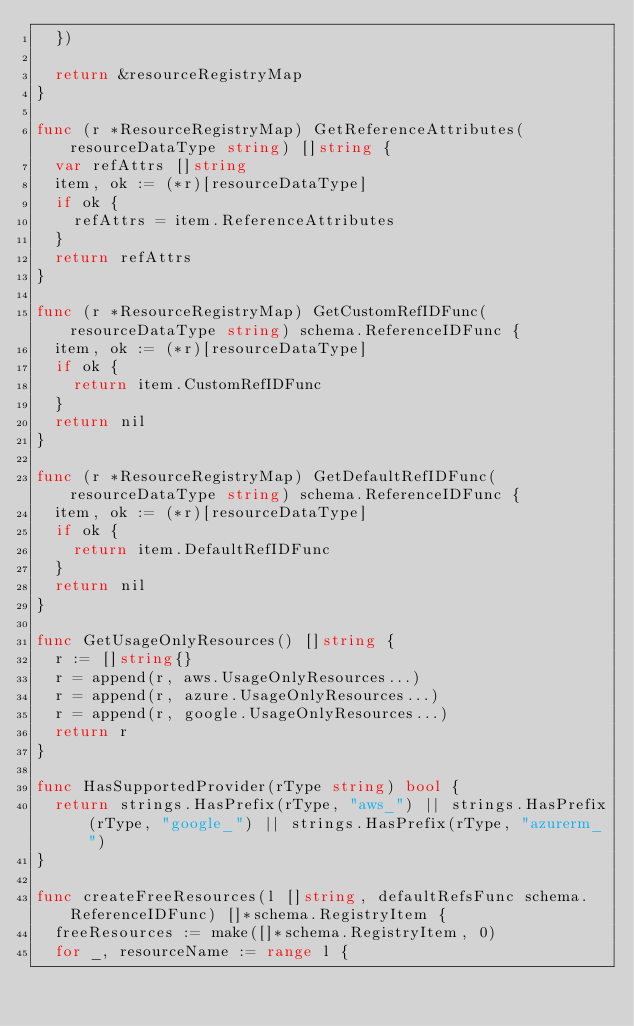Convert code to text. <code><loc_0><loc_0><loc_500><loc_500><_Go_>	})

	return &resourceRegistryMap
}

func (r *ResourceRegistryMap) GetReferenceAttributes(resourceDataType string) []string {
	var refAttrs []string
	item, ok := (*r)[resourceDataType]
	if ok {
		refAttrs = item.ReferenceAttributes
	}
	return refAttrs
}

func (r *ResourceRegistryMap) GetCustomRefIDFunc(resourceDataType string) schema.ReferenceIDFunc {
	item, ok := (*r)[resourceDataType]
	if ok {
		return item.CustomRefIDFunc
	}
	return nil
}

func (r *ResourceRegistryMap) GetDefaultRefIDFunc(resourceDataType string) schema.ReferenceIDFunc {
	item, ok := (*r)[resourceDataType]
	if ok {
		return item.DefaultRefIDFunc
	}
	return nil
}

func GetUsageOnlyResources() []string {
	r := []string{}
	r = append(r, aws.UsageOnlyResources...)
	r = append(r, azure.UsageOnlyResources...)
	r = append(r, google.UsageOnlyResources...)
	return r
}

func HasSupportedProvider(rType string) bool {
	return strings.HasPrefix(rType, "aws_") || strings.HasPrefix(rType, "google_") || strings.HasPrefix(rType, "azurerm_")
}

func createFreeResources(l []string, defaultRefsFunc schema.ReferenceIDFunc) []*schema.RegistryItem {
	freeResources := make([]*schema.RegistryItem, 0)
	for _, resourceName := range l {</code> 